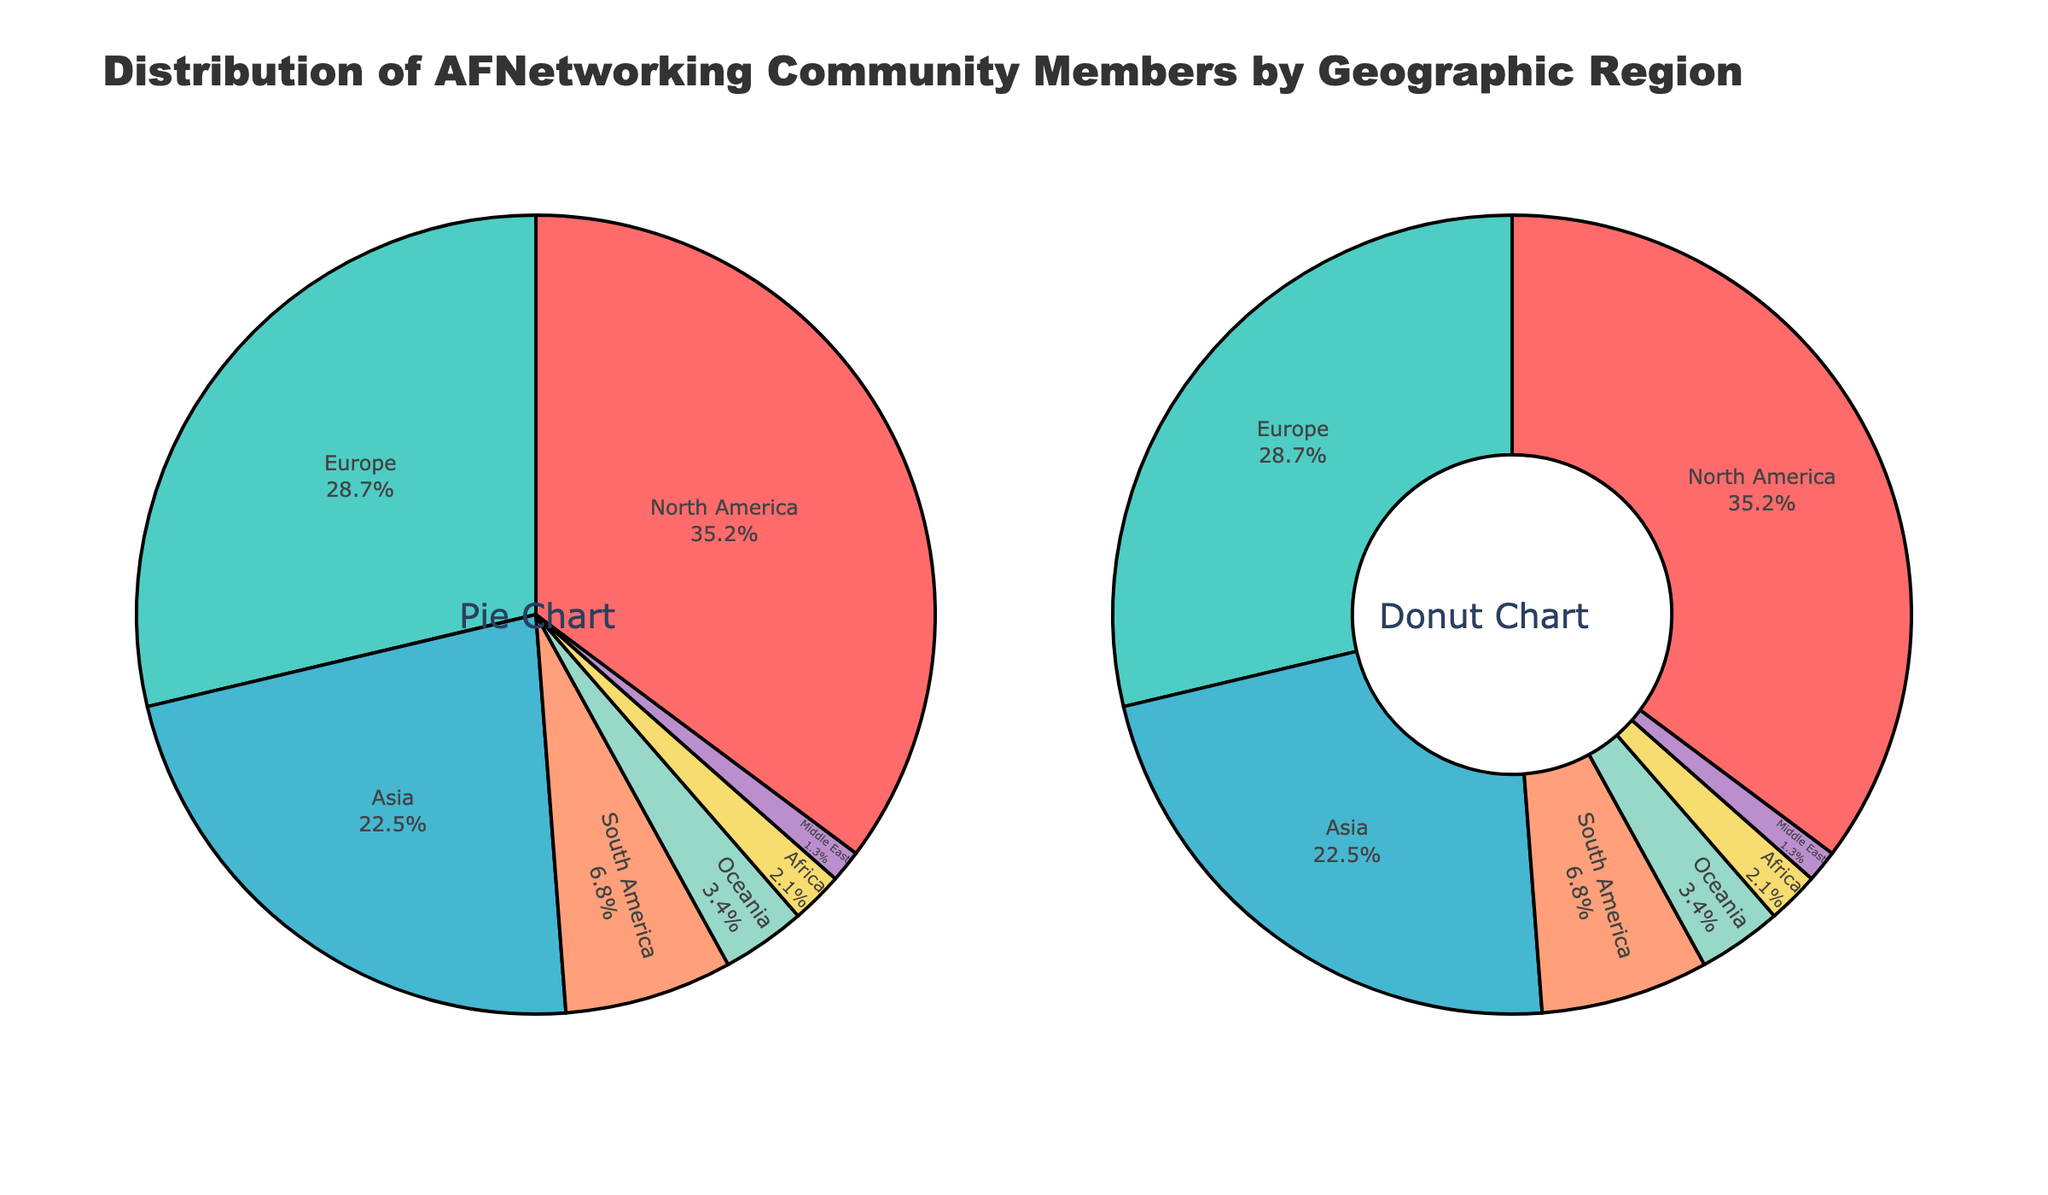What's the largest geographic region represented? North America has the highest percentage of AFNetworking community members, comprising 35.2% of the total.
Answer: North America What's the combined percentage of community members from Europe and Asia? Europe represents 28.7% and Asia 22.5%, so their combined percentage is 28.7 + 22.5 = 51.2%.
Answer: 51.2% Which region has a larger share, South America or Oceania? South America has 6.8%, whereas Oceania has 3.4%. Therefore, South America has a larger share than Oceania.
Answer: South America How much higher is the percentage of North America compared to Africa? North America is at 35.2% and Africa at 2.1%. The difference is 35.2 - 2.1 = 33.1%.
Answer: 33.1% What's the total percentage for all regions except North America? Adding percentages of all regions except North America: 28.7 + 22.5 + 6.8 + 3.4 + 2.1 + 1.3 = 64.8%.
Answer: 64.8% Between Asia and Europe, which region has a smaller percentage of members, and by how much? Asia has 22.5% while Europe has 28.7%. Therefore, Asia has a smaller percentage by 28.7 - 22.5 = 6.2%.
Answer: Asia by 6.2% What is the ratio of community members in North America to those in the Middle East? North America is 35.2% and the Middle East is 1.3%. The ratio is 35.2 / 1.3 ≈ 27.08.
Answer: 27.08 What percentage of the community is from regions outside of Europe and Asia? Sum the percentages of all regions except Europe and Asia: 35.2 + 6.8 + 3.4 + 2.1 + 1.3 = 48.8%.
Answer: 48.8% Which region has the smallest representation within the community? The Middle East has the smallest representation with 1.3%.
Answer: Middle East 